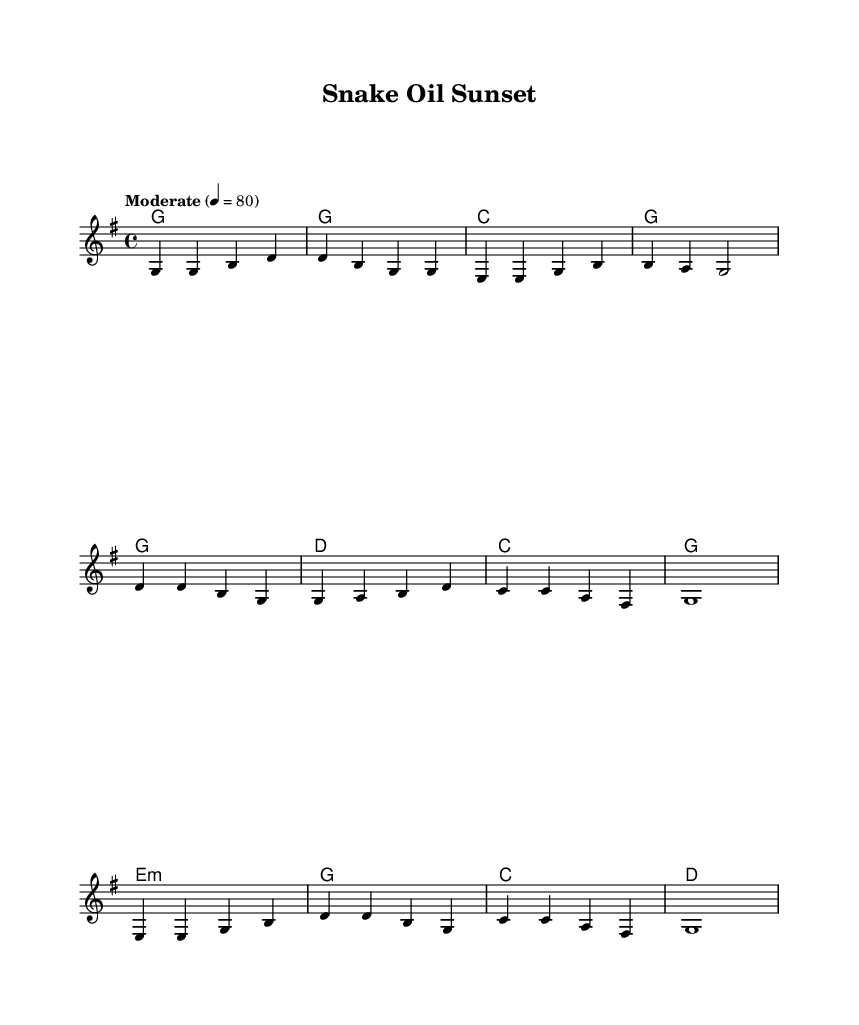What is the key signature of this music? The key signature is indicated at the beginning of the score. The symbol shown corresponds to G major, which has one sharp (F#).
Answer: G major What is the time signature of this music? The time signature appears at the start of the score. It shows a "4/4" indicating that there are four beats in a measure and the quarter note gets one beat.
Answer: 4/4 What is the tempo marking for this piece? The tempo marking is found near the top of the score, indicating how fast the piece should be played. It is set to "Moderate" with a metronome mark of 80 beats per minute.
Answer: Moderate 4 = 80 How many measures are in the verse? The verse consists of four measures as indicated by the grouping of notes before the chorus starts.
Answer: 4 Which chord is indicated in the chorus? The chord that appears in the chorus each time is the 'G' chord, which is consistent across the chorus lines.
Answer: G What is the theme of the lyrics in this song? The lyrics reflect the disillusionment with life coaching and self-help schemes. This thematic focus can be verified by checking the context of each verse.
Answer: Disillusionment What is the structure of the song? The song is structured with a verse followed by a chorus, and then a bridge. The sections can be identified by looking at how the lyrics and melodies are organized sequentially.
Answer: Verse, Chorus, Bridge 